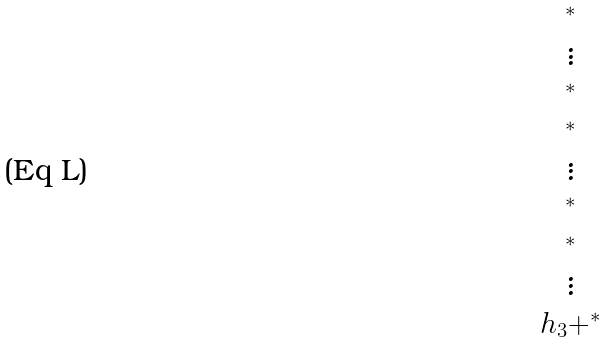Convert formula to latex. <formula><loc_0><loc_0><loc_500><loc_500>\begin{matrix} ^ { * } \\ \vdots \\ ^ { * } \\ ^ { * } \\ \vdots \\ ^ { * } \\ ^ { * } \\ \vdots \\ h _ { 3 } + ^ { * } \end{matrix}</formula> 